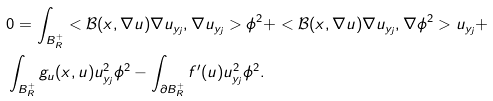<formula> <loc_0><loc_0><loc_500><loc_500>& 0 = \int _ { { B } _ { R } ^ { + } } < \mathcal { B } ( x , \nabla u ) \nabla u _ { y _ { j } } , \nabla u _ { y _ { j } } > \phi ^ { 2 } + < \mathcal { B } ( x , \nabla u ) \nabla u _ { y _ { j } } , \nabla \phi ^ { 2 } > u _ { y _ { j } } + \\ & \int _ { B _ { R } ^ { + } } g _ { u } ( x , u ) u _ { y _ { j } } ^ { 2 } \phi ^ { 2 } - \int _ { \partial B _ { R } ^ { + } } f ^ { \prime } ( u ) u _ { y _ { j } } ^ { 2 } \phi ^ { 2 } .</formula> 